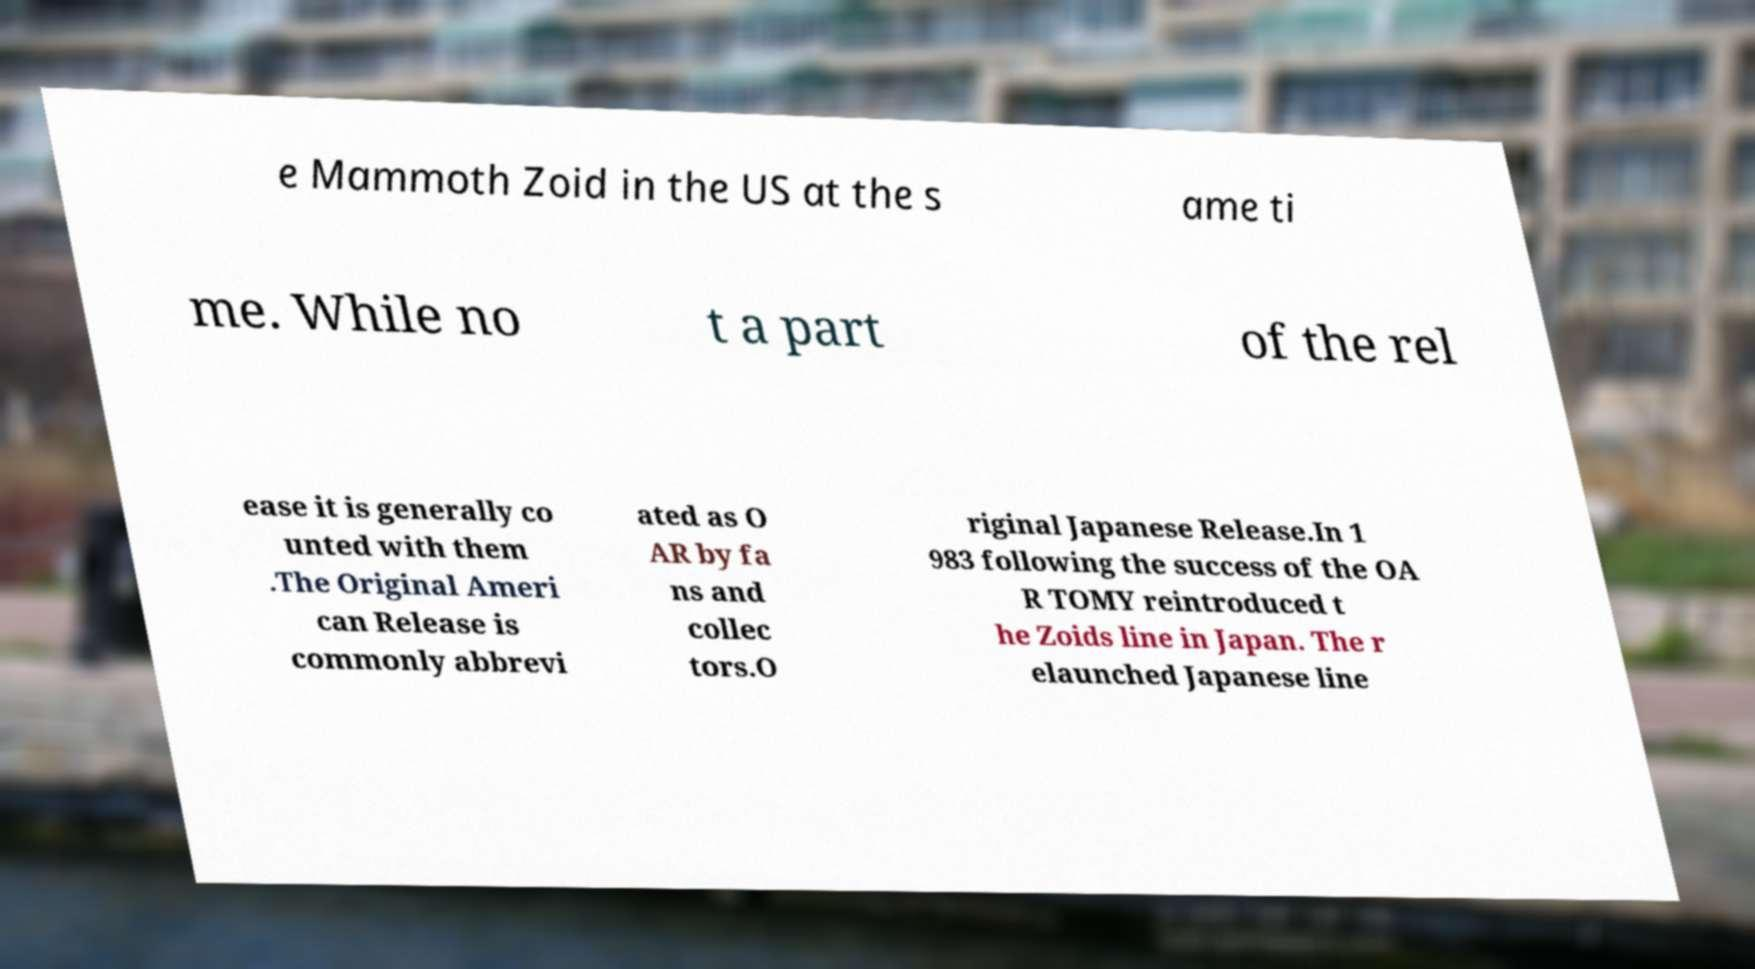Could you assist in decoding the text presented in this image and type it out clearly? e Mammoth Zoid in the US at the s ame ti me. While no t a part of the rel ease it is generally co unted with them .The Original Ameri can Release is commonly abbrevi ated as O AR by fa ns and collec tors.O riginal Japanese Release.In 1 983 following the success of the OA R TOMY reintroduced t he Zoids line in Japan. The r elaunched Japanese line 